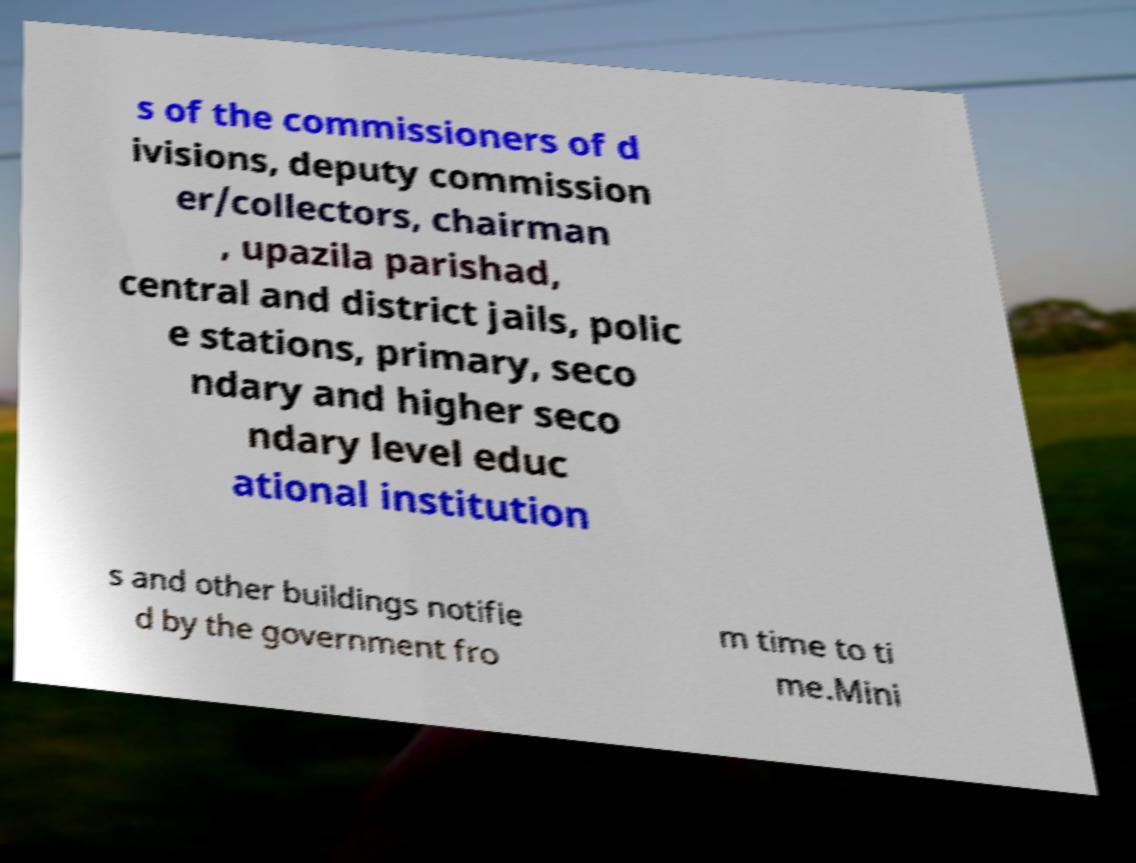Could you extract and type out the text from this image? s of the commissioners of d ivisions, deputy commission er/collectors, chairman , upazila parishad, central and district jails, polic e stations, primary, seco ndary and higher seco ndary level educ ational institution s and other buildings notifie d by the government fro m time to ti me.Mini 